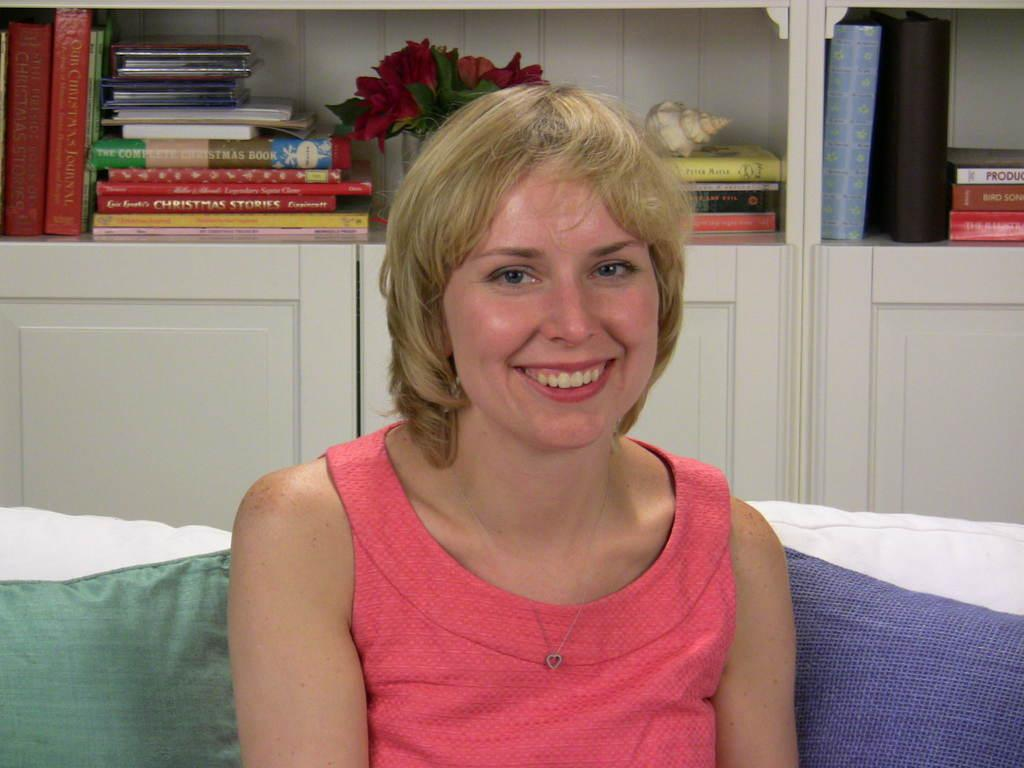Who is the main subject in the image? There is a lady in the image. What is the lady doing in the image? The lady is sitting on a sofa. Where is the sofa located in the image? The sofa is in the center of the image. What can be seen in the background of the image? There are cupboards, books, and a flower vase in the background of the image. What type of yoke is being used by the lady in the image? There is no yoke present in the image; the lady is sitting on a sofa. Can you provide more details about the quarter in the image? There is no mention of a quarter in the image; the focus is on the lady, the sofa, and the background elements. 